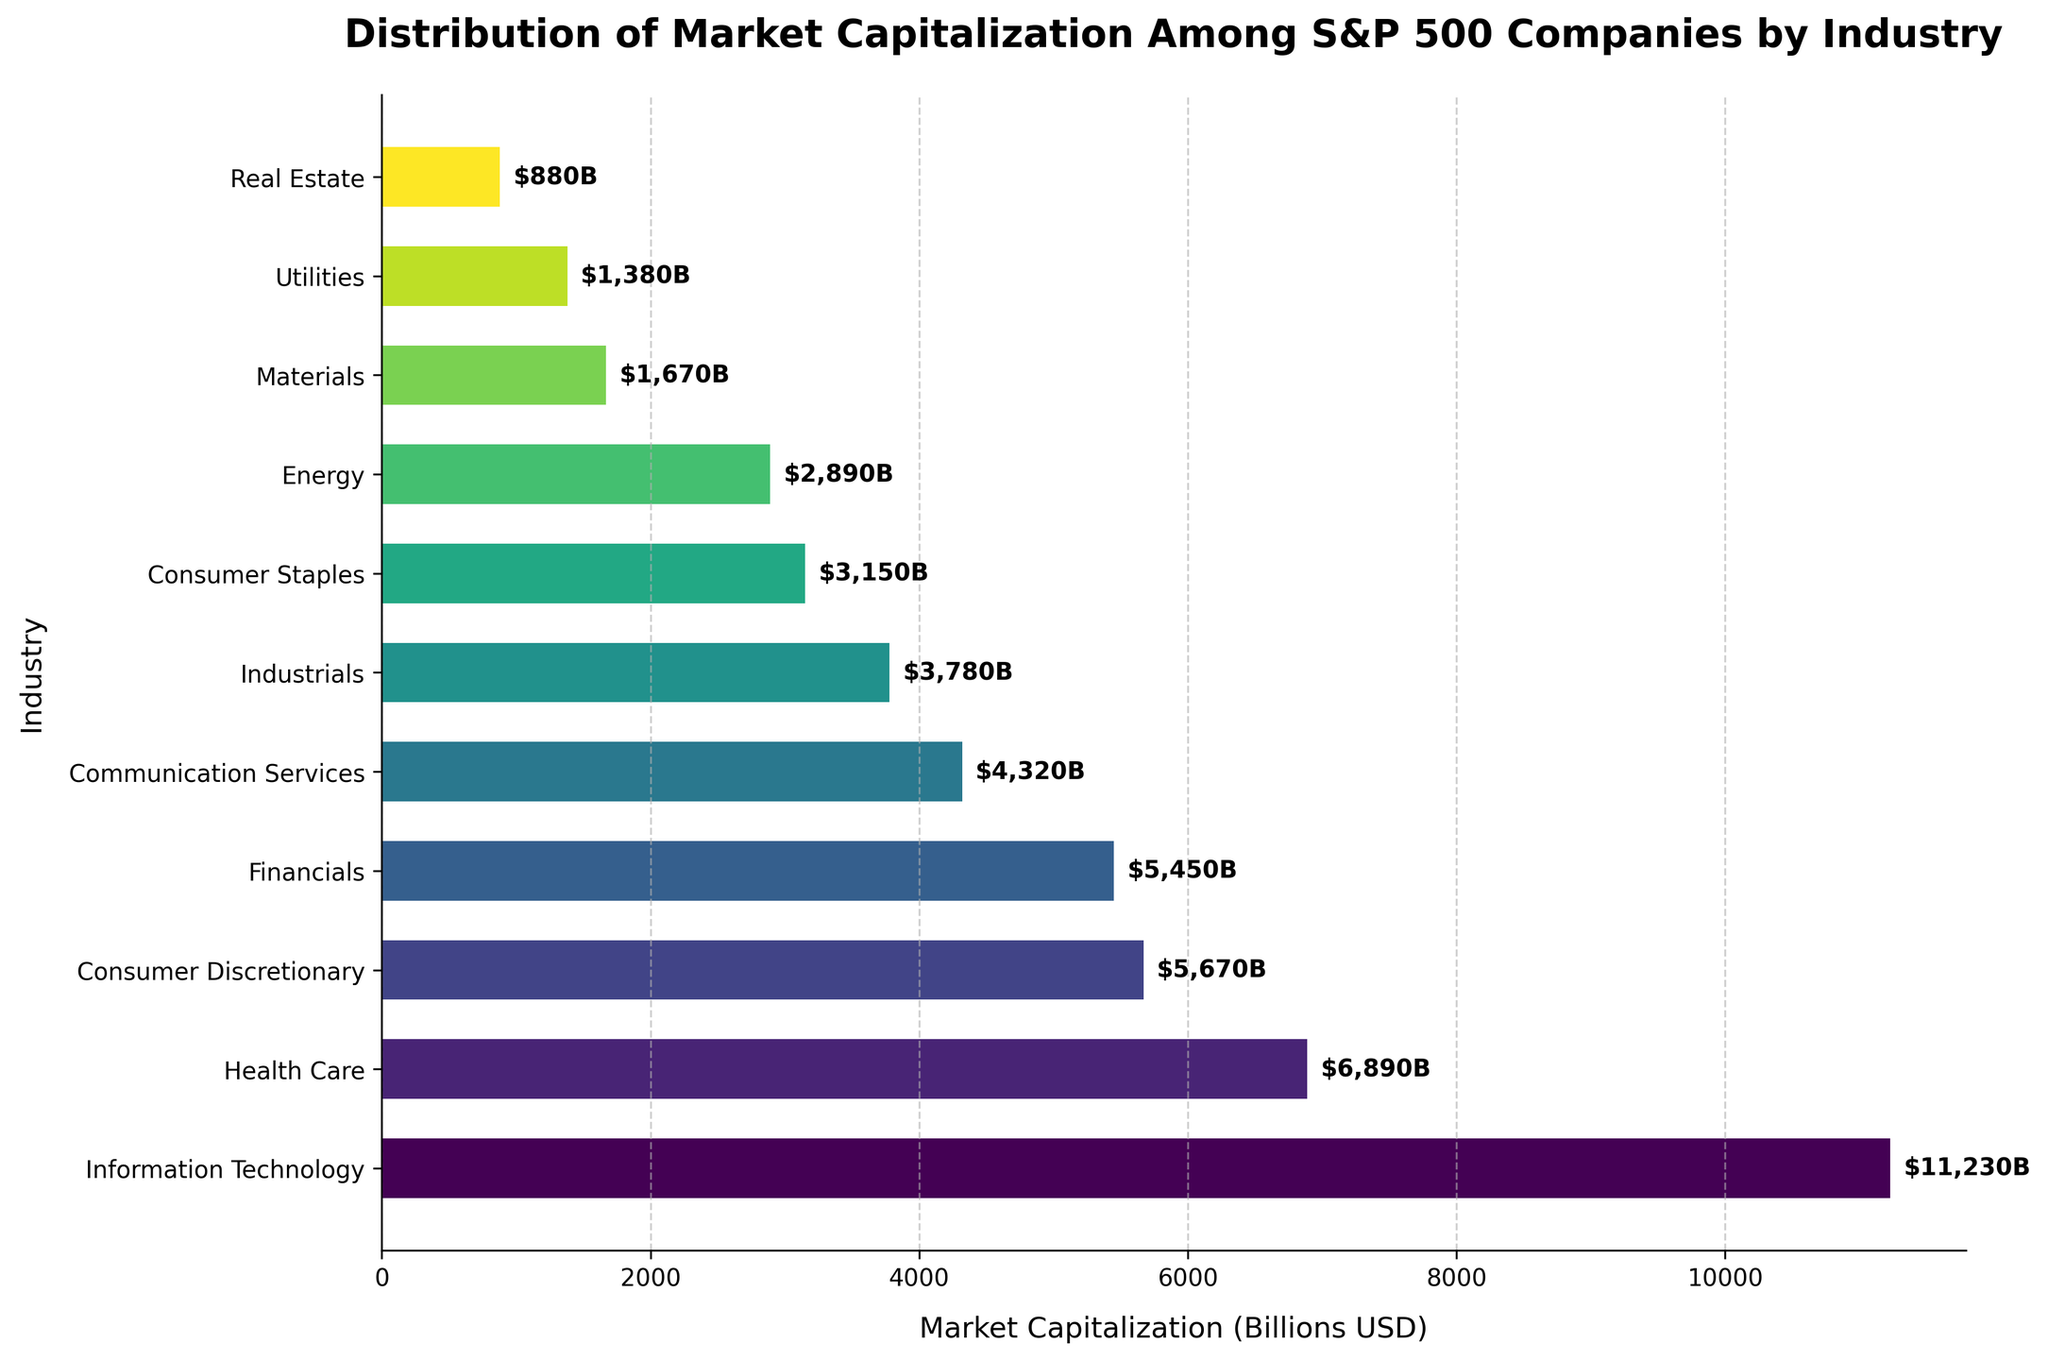What is the industry with the highest market capitalization in the S&P 500? The industry with the highest market capitalization can be identified by looking for the bar with the greatest length. It represents Information Technology.
Answer: Information Technology Which industry has a higher market capitalization, Health Care or Financials? By comparing the lengths of the bars representing Health Care and Financials, Health Care's bar is longer, indicating it has a higher market capitalization.
Answer: Health Care How much more is the market capitalization of Consumer Discretionary compared to Energy? First, find the bars labeled Consumer Discretionary ($5,670B) and Energy ($2,890B). Then subtract the market capitalization of Energy from Consumer Discretionary: $5,670B - $2,890B.
Answer: $2,780B What is the total market capitalization of the bottom three industries? Identify the three industries with the shortest bars: Real Estate ($880B), Utilities ($1,380B), and Materials ($1,670B). Calculate the sum: $880B + $1,380B + $1,670B.
Answer: $3,930B Is the market capitalization of Financials greater than the combined market capitalization of Energy and Utilities? Compare the market capitalization of Financials ($5,450B) to the sum of Energy ($2,890B) and Utilities ($1,380B). First, calculate the sum: $2,890B + $1,380B = $4,270B. Since $5,450B is greater than $4,270B, Financials' market capitalization is larger.
Answer: Yes What is the total market capitalization of the top four industries? Identify the top four industries by market capitalization: Information Technology ($11,230B), Health Care ($6,890B), Consumer Discretionary ($5,670B), and Financials ($5,450B). Calculate the total sum: $11,230B + $6,890B + $5,670B + $5,450B.
Answer: $29,240B Which industry has the smallest market capitalization and by how much is it less than Communication Services? The industry with the smallest market capitalization is Real Estate ($880B). Compare it to Communication Services ($4,320B) by subtracting Real Estate's market capitalization from Communication Services: $4,320B - $880B.
Answer: $3,440B Is the sum of market capitalizations for Health Care and Consumer Staples greater than that for Information Technology? Add Health Care ($6,890B) and Consumer Staples ($3,150B) to get $10,040B. Compare it to Information Technology ($11,230B). Since $10,040B is less than $11,230B, the sum is not greater.
Answer: No Rank the industries by market capitalization in descending order. List the industries corresponding to the lengths of the bars from longest to shortest. The order is: Information Technology, Health Care, Consumer Discretionary, Financials, Communication Services, Industrials, Consumer Staples, Energy, Materials, Utilities, Real Estate.
Answer: Information Technology, Health Care, Consumer Discretionary, Financials, Communication Services, Industrials, Consumer Staples, Energy, Materials, Utilities, Real Estate 